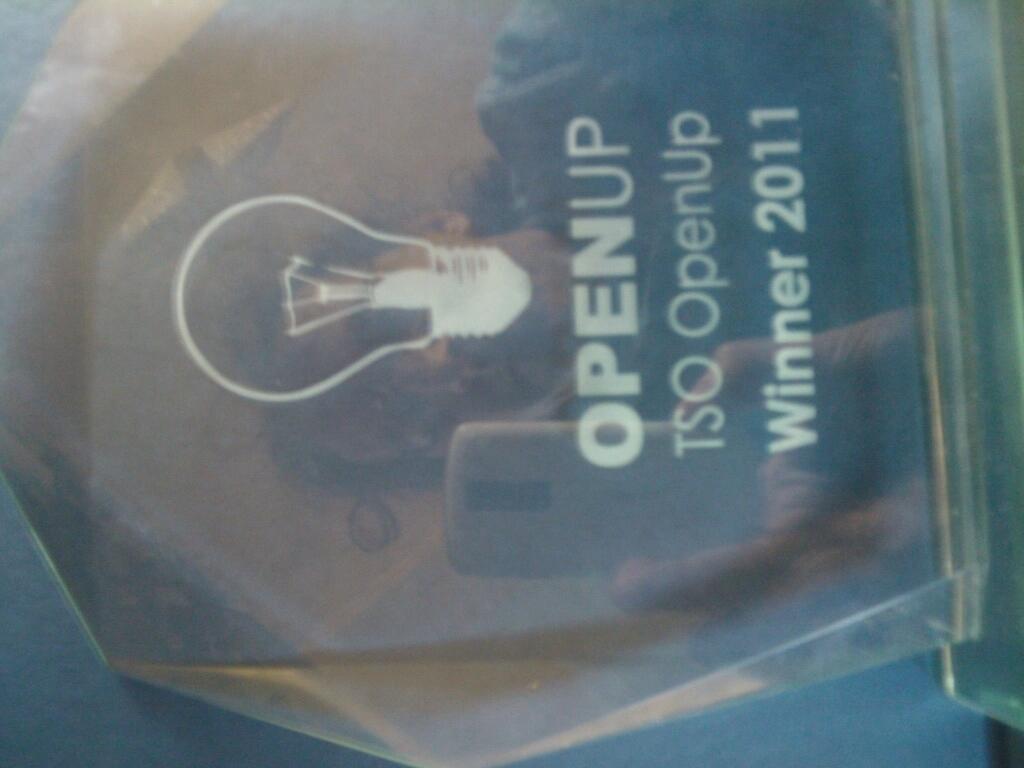Can you describe this image briefly? In the image there is a award with a reflection of woman holding a cellphone on it. 